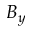<formula> <loc_0><loc_0><loc_500><loc_500>B _ { y }</formula> 